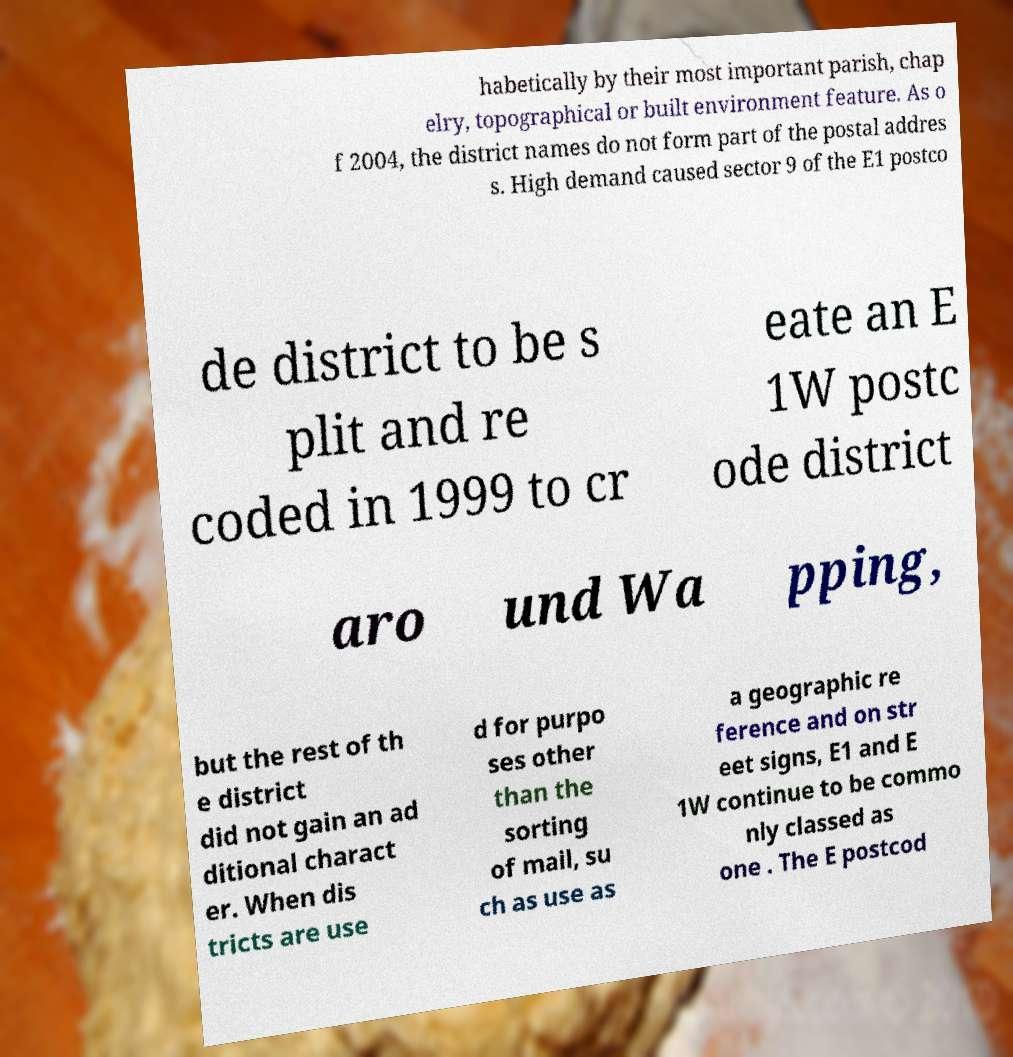There's text embedded in this image that I need extracted. Can you transcribe it verbatim? habetically by their most important parish, chap elry, topographical or built environment feature. As o f 2004, the district names do not form part of the postal addres s. High demand caused sector 9 of the E1 postco de district to be s plit and re coded in 1999 to cr eate an E 1W postc ode district aro und Wa pping, but the rest of th e district did not gain an ad ditional charact er. When dis tricts are use d for purpo ses other than the sorting of mail, su ch as use as a geographic re ference and on str eet signs, E1 and E 1W continue to be commo nly classed as one . The E postcod 